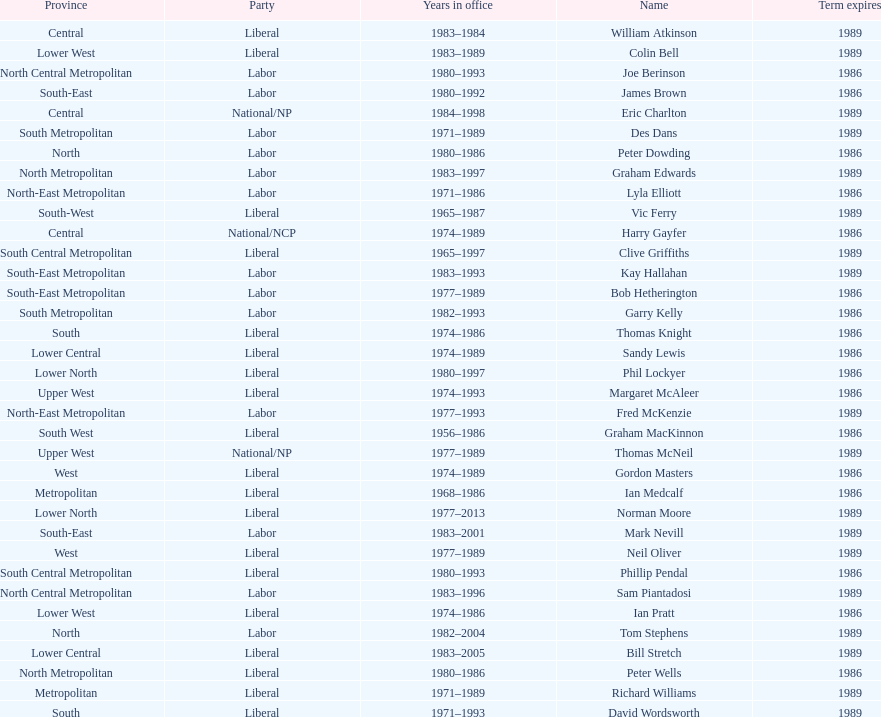What is the number of people in the liberal party? 19. 